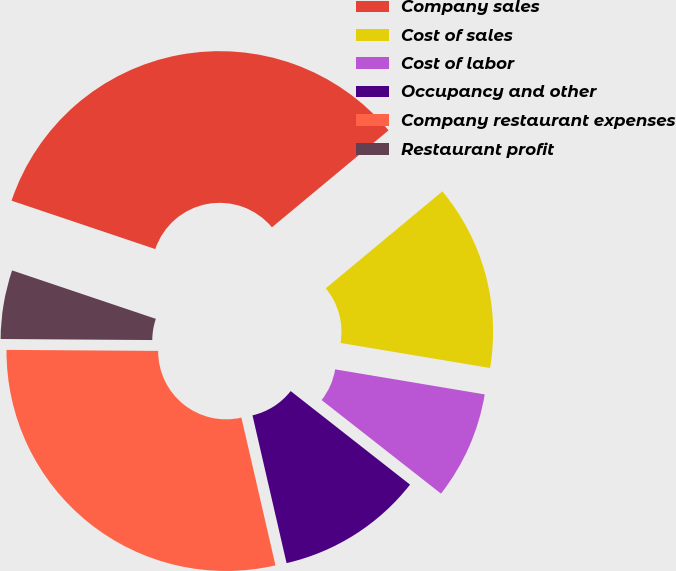Convert chart. <chart><loc_0><loc_0><loc_500><loc_500><pie_chart><fcel>Company sales<fcel>Cost of sales<fcel>Cost of labor<fcel>Occupancy and other<fcel>Company restaurant expenses<fcel>Restaurant profit<nl><fcel>33.79%<fcel>13.68%<fcel>7.94%<fcel>10.81%<fcel>28.72%<fcel>5.06%<nl></chart> 